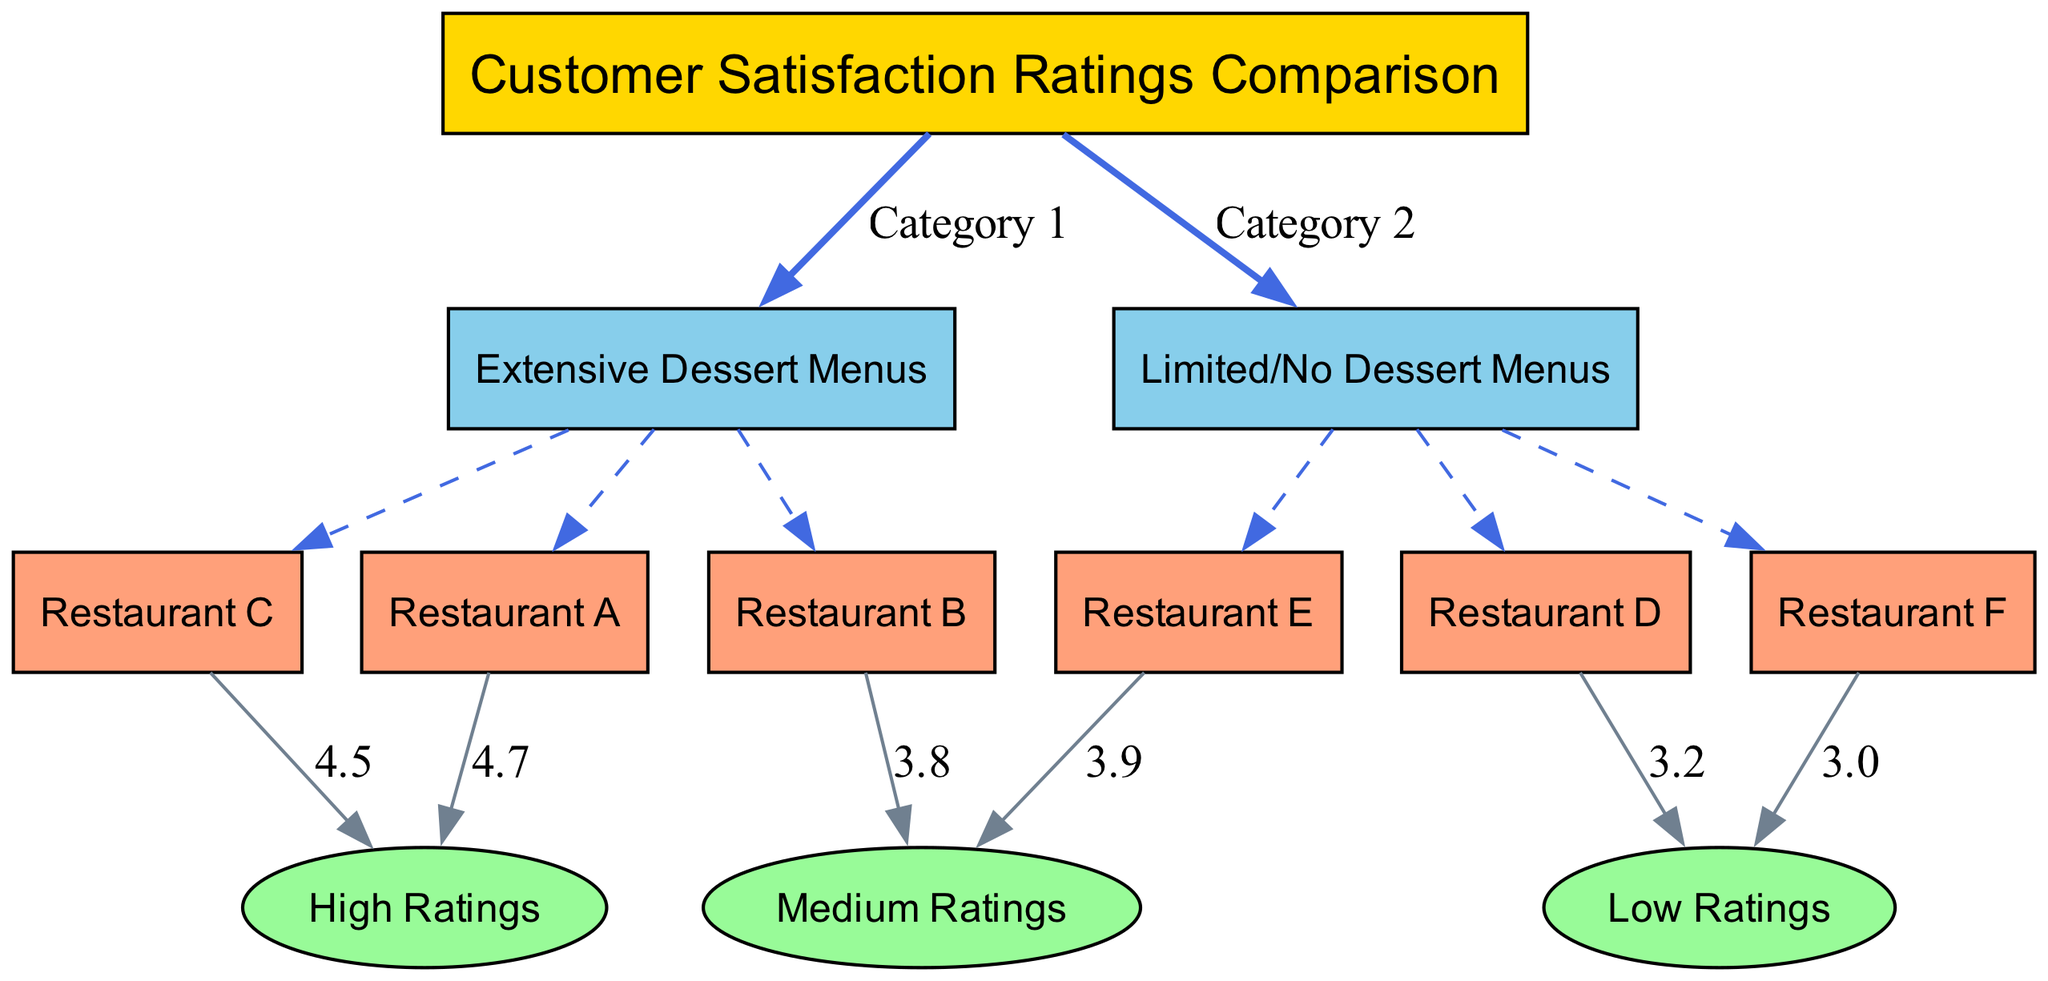What are the two main categories compared in the diagram? The diagram has a main node that connects to "Extensive Dessert Menus" and "Limited/No Dessert Menus," which are the two primary categories of comparison.
Answer: Extensive Dessert Menus, Limited/No Dessert Menus How many restaurants are categorized under Extensive Dessert Menus? In the diagram, the node "Extensive Dessert Menus" has three connecting restaurants: Restaurant A, B, and C. Therefore, there are three restaurants in this category.
Answer: 3 Which restaurant has the highest customer satisfaction rating? As seen in the diagram, Restaurant A is connected to the "High Ratings" node with a rating of 4.7, making it the highest-rated restaurant.
Answer: Restaurant A What is the medium rating of Restaurant E? The diagram shows that Restaurant E connects to the "Medium Ratings" node, which implies that its customer satisfaction rating is categorized as medium. The diagram specifies a rating of 3.9.
Answer: 3.9 What is the rating of Restaurant D? The diagram indicates that Restaurant D is connected to the "Low Ratings" node with a specific rating of 3.2, stating its customer satisfaction level.
Answer: 3.2 How many restaurants have low customer satisfaction ratings? By tracing connections from the "Low Ratings" node, we find that Restaurant D and Restaurant F are both linked to this rating, totaling two restaurants.
Answer: 2 Which category has more restaurants connected to it, Extensive Dessert Menus or Limited/No Dessert Menus? "Extensive Dessert Menus" has three restaurants (A, B, C), while "Limited/No Dessert Menus" has three restaurants (D, E, F) as well. Therefore, both categories are equal in number.
Answer: Equal What is the rating of Restaurant F? The diagram shows that Restaurant F is connected to the "Low Ratings" node with a low rating of 3.0 explicitly stated in the label.
Answer: 3.0 Which restaurant has a rating of 4.5? The diagram indicates that Restaurant C is linked to the "High Ratings" node through a connection, specifying a rating of 4.5.
Answer: Restaurant C 